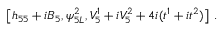Convert formula to latex. <formula><loc_0><loc_0><loc_500><loc_500>\left [ h _ { 5 5 } + i B _ { 5 } , \psi _ { 5 L } ^ { 2 } , V _ { 5 } ^ { 1 } + i V _ { 5 } ^ { 2 } + 4 i ( t ^ { 1 } + i t ^ { 2 } ) \right ] \, .</formula> 